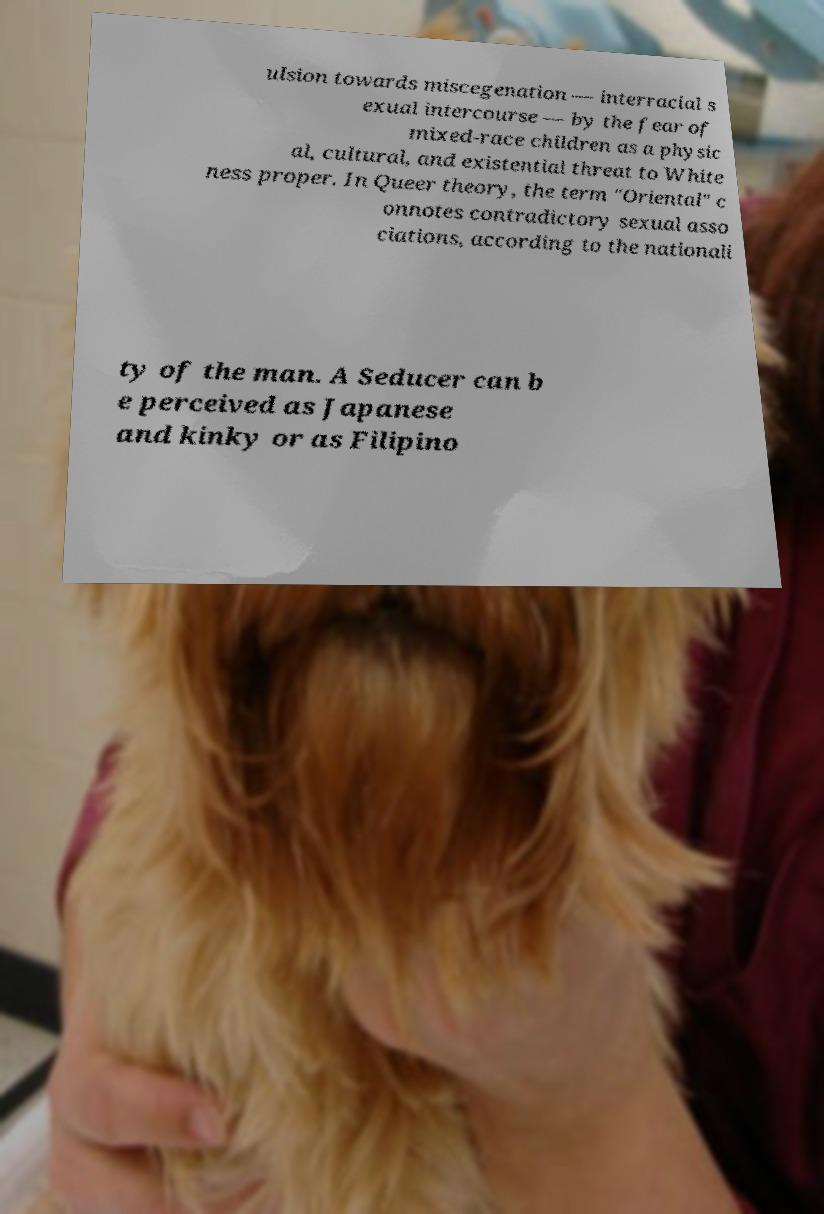What messages or text are displayed in this image? I need them in a readable, typed format. ulsion towards miscegenation — interracial s exual intercourse — by the fear of mixed-race children as a physic al, cultural, and existential threat to White ness proper. In Queer theory, the term "Oriental" c onnotes contradictory sexual asso ciations, according to the nationali ty of the man. A Seducer can b e perceived as Japanese and kinky or as Filipino 